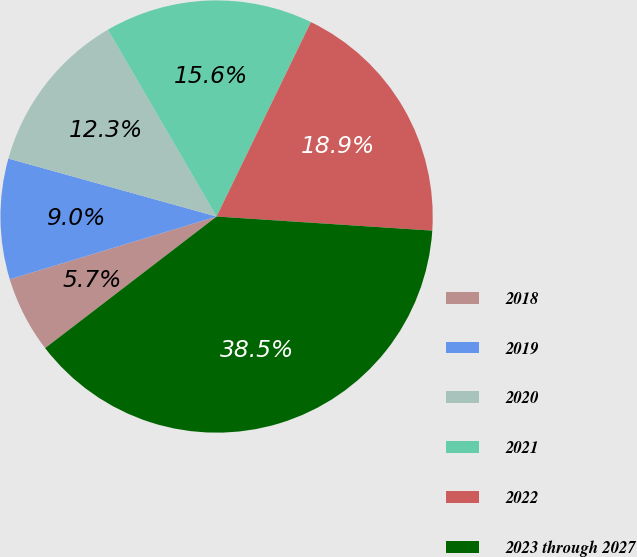<chart> <loc_0><loc_0><loc_500><loc_500><pie_chart><fcel>2018<fcel>2019<fcel>2020<fcel>2021<fcel>2022<fcel>2023 through 2027<nl><fcel>5.73%<fcel>9.01%<fcel>12.29%<fcel>15.57%<fcel>18.85%<fcel>38.54%<nl></chart> 